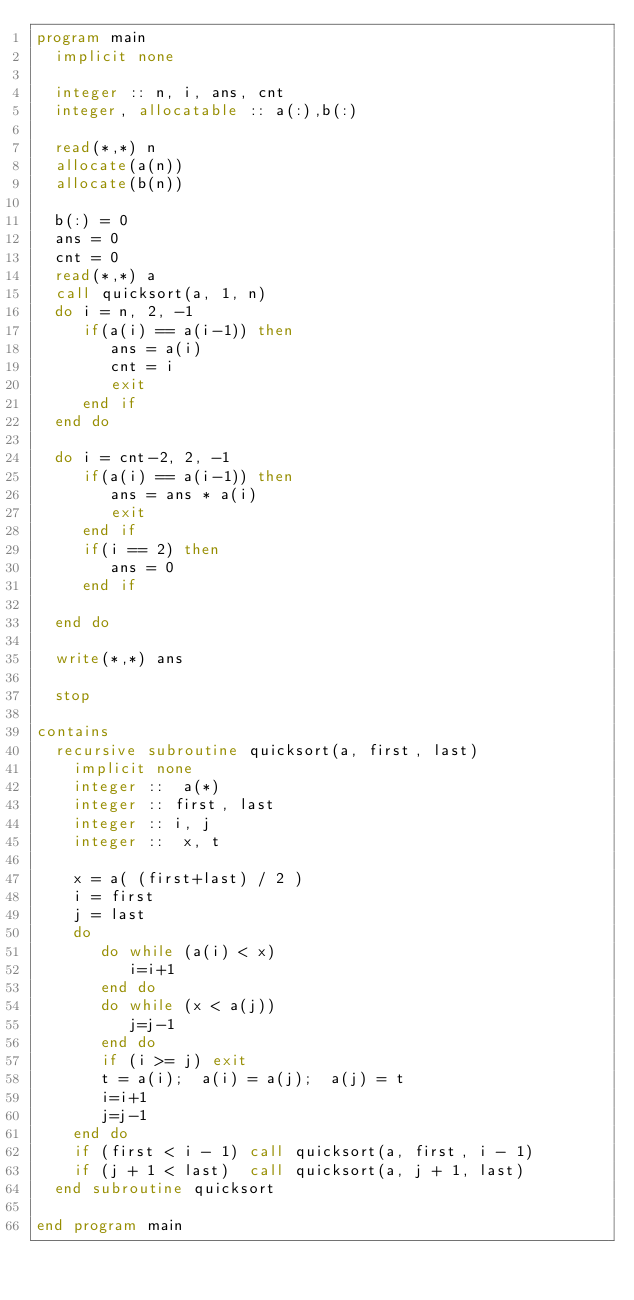Convert code to text. <code><loc_0><loc_0><loc_500><loc_500><_FORTRAN_>program main
  implicit none

  integer :: n, i, ans, cnt
  integer, allocatable :: a(:),b(:)

  read(*,*) n
  allocate(a(n))
  allocate(b(n))

  b(:) = 0
  ans = 0
  cnt = 0
  read(*,*) a
  call quicksort(a, 1, n)
  do i = n, 2, -1
     if(a(i) == a(i-1)) then
        ans = a(i)
        cnt = i
        exit
     end if
  end do

  do i = cnt-2, 2, -1
     if(a(i) == a(i-1)) then
        ans = ans * a(i)
        exit
     end if
     if(i == 2) then
        ans = 0
     end if
     
  end do

  write(*,*) ans

  stop
  
contains
  recursive subroutine quicksort(a, first, last)
    implicit none
    integer ::  a(*)
    integer :: first, last
    integer :: i, j
    integer ::  x, t
    
    x = a( (first+last) / 2 )
    i = first
    j = last
    do
       do while (a(i) < x)
          i=i+1
       end do
       do while (x < a(j))
          j=j-1
       end do
       if (i >= j) exit
       t = a(i);  a(i) = a(j);  a(j) = t
       i=i+1
       j=j-1
    end do
    if (first < i - 1) call quicksort(a, first, i - 1)
    if (j + 1 < last)  call quicksort(a, j + 1, last)
  end subroutine quicksort

end program main

  
</code> 